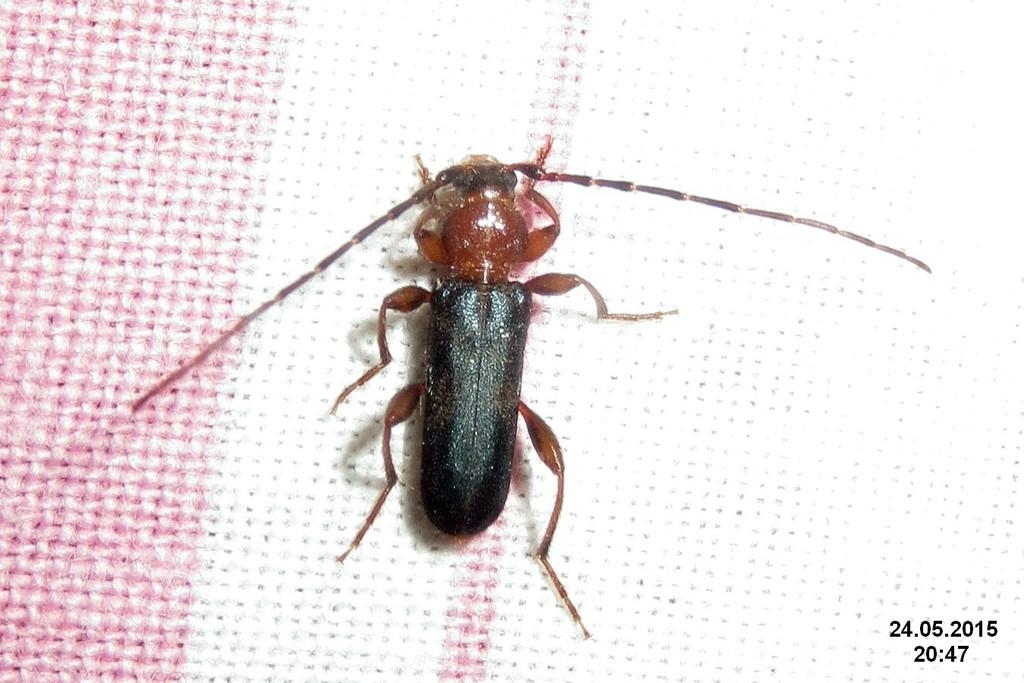What is the main subject in the center of the image? There is a soldier beetle in the center of the image. What type of calculator can be seen in the image? There is no calculator present in the image; it features a soldier beetle. What type of yard is visible in the image? There is no yard present in the image; it features a soldier beetle. 